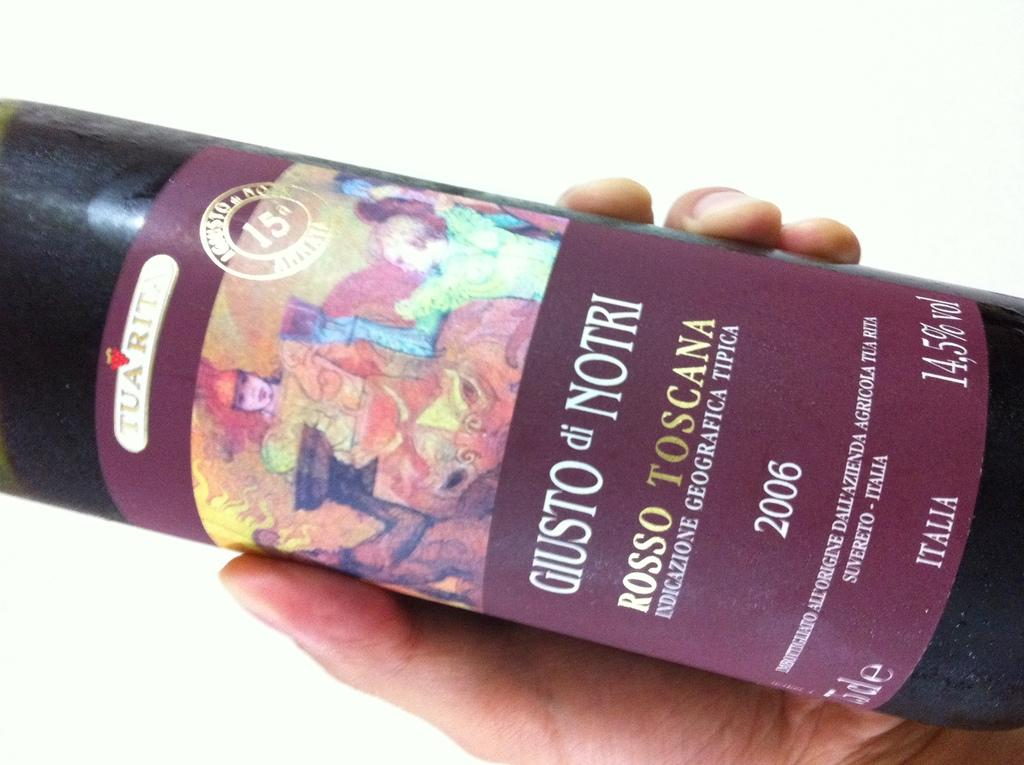Provide a one-sentence caption for the provided image. A bottle of GIUSTO di NORTI red wine. 